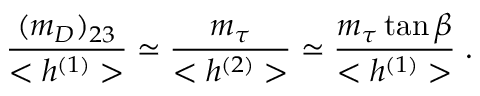Convert formula to latex. <formula><loc_0><loc_0><loc_500><loc_500>\frac { ( m _ { D } ) _ { 2 3 } } { < h ^ { ( 1 ) } > } \simeq \frac { m _ { \tau } } { < h ^ { ( 2 ) } > } \simeq \frac { m _ { \tau } \tan \beta } { < h ^ { ( 1 ) } > } \, .</formula> 